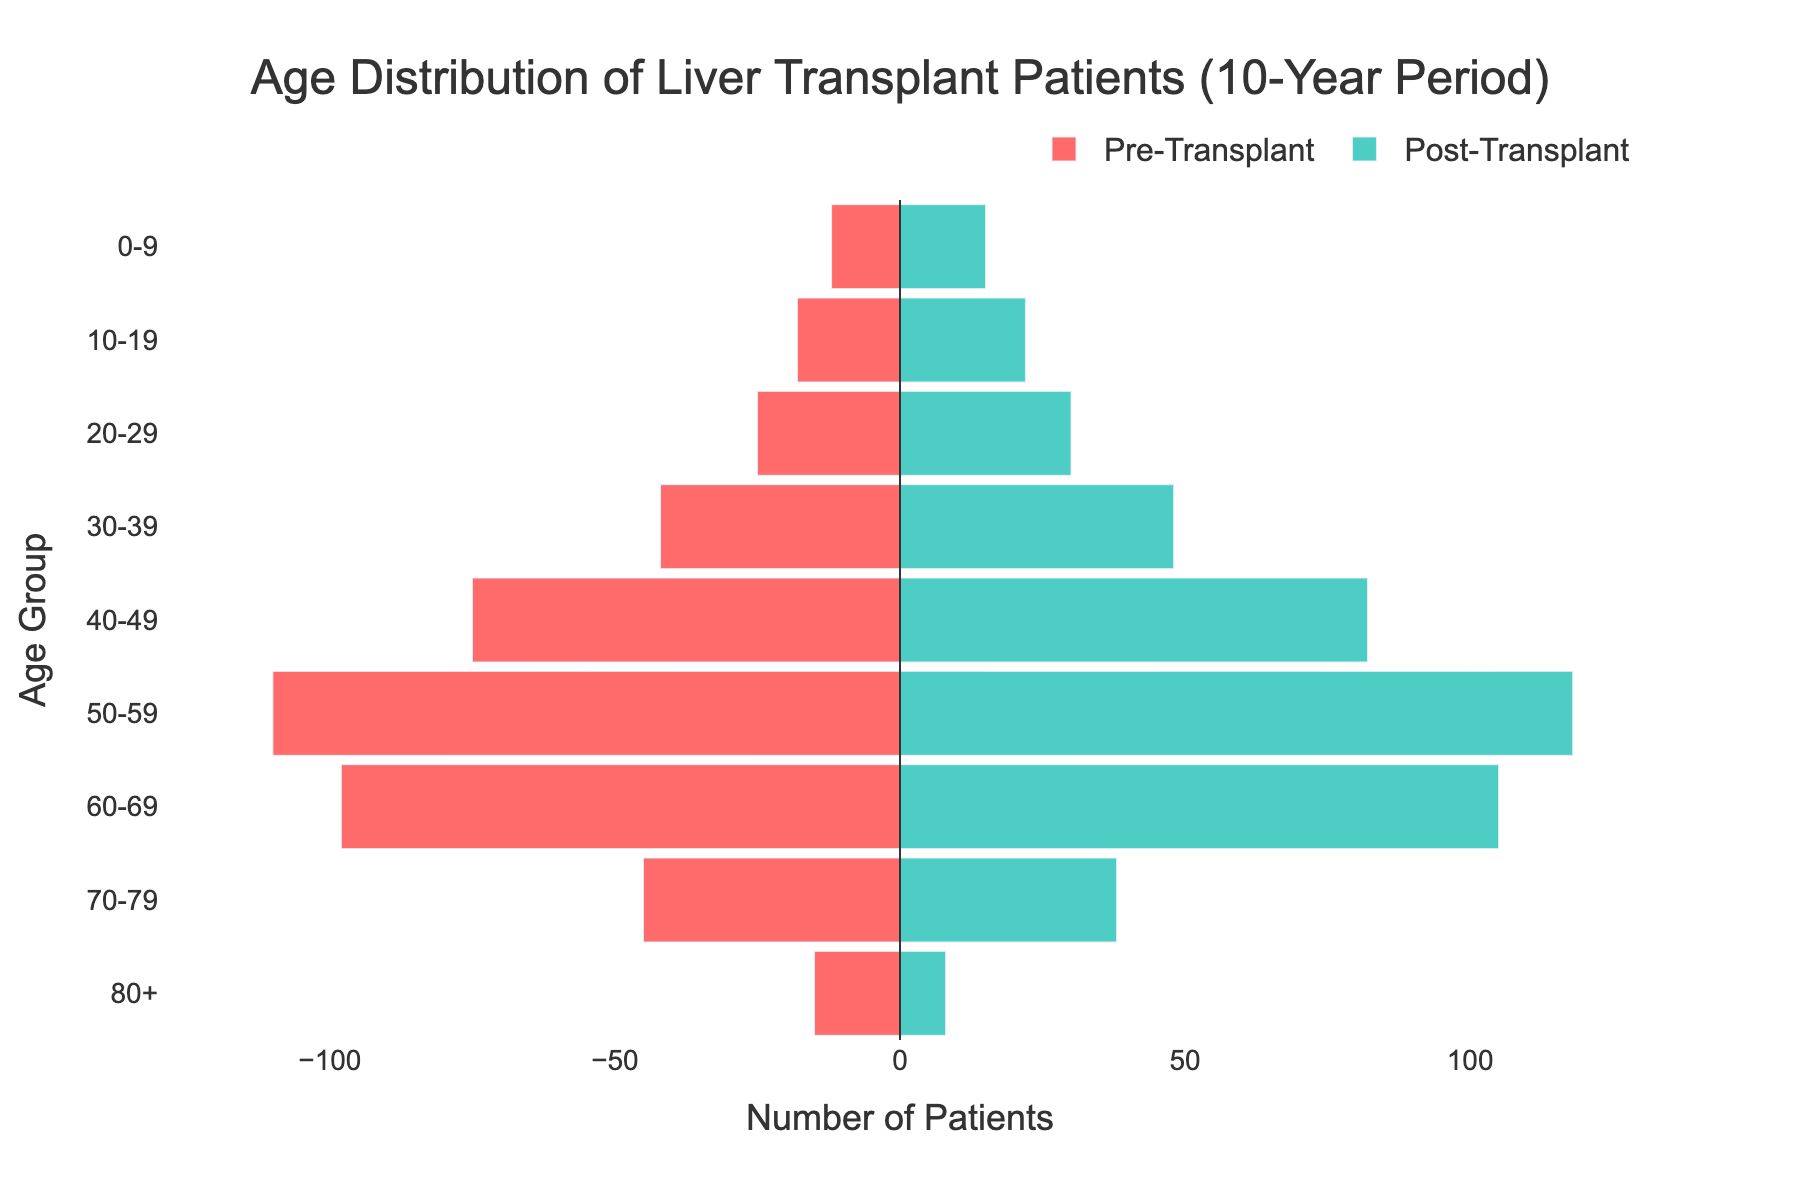What is the title of the plot? The title can be found at the top of the plot, usually in a larger font size.
Answer: Age Distribution of Liver Transplant Patients (10-Year Period) How many age groups are included in the plot? The age groups can be read on the y-axis labels, which list them vertically.
Answer: 9 Which age group has the highest number of post-transplant patients? By comparing the lengths of the bars on the right side (post-transplant) of the figure, the 50-59 age group has the longest bar.
Answer: 50-59 How many pre-transplant patients are there in the 40-49 age group? The number of pre-transplant patients in each age group is indicated by the length of the bars on the left side. For 40-49, the bar indicates 75 patients.
Answer: 75 What is the color used to represent post-transplant patients? The legend on the bottom part of the plot indicates the color used for post-transplant patients.
Answer: Teal Which age group has the smallest number of pre-transplant patients? By examining the lengths of the bars on the left side, the 0-9 age group has the shortest bar.
Answer: 0-9 What is the total number of patients in the 60-69 age group when combining pre- and post-transplant numbers? Sum the pre-transplant (98) and post-transplant (105) patients in the 60-69 age group.
Answer: 203 In which age group do we see a decrease in the number of patients from pre- to post-transplant? By comparing the length of bars on both sides, the 70-79 and 80+ age groups have fewer post-transplant patients than pre-transplant patients.
Answer: 70-79, 80+ Is there a significant visual difference between the pre- and post-transplant numbers in the 30-39 age group? Comparing the bar lengths on both sides shows that the numbers are similar, indicating no significant difference.
Answer: No 